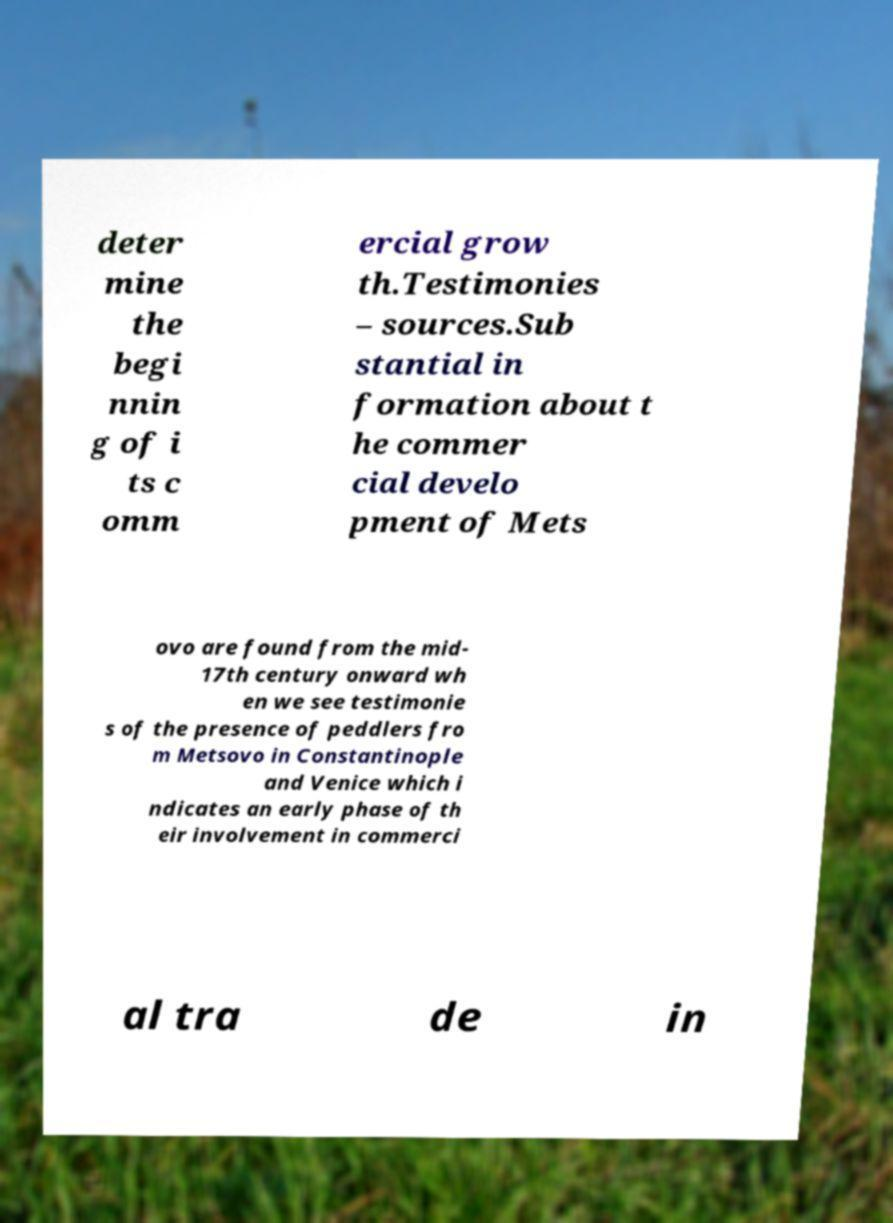What messages or text are displayed in this image? I need them in a readable, typed format. deter mine the begi nnin g of i ts c omm ercial grow th.Testimonies – sources.Sub stantial in formation about t he commer cial develo pment of Mets ovo are found from the mid- 17th century onward wh en we see testimonie s of the presence of peddlers fro m Metsovo in Constantinople and Venice which i ndicates an early phase of th eir involvement in commerci al tra de in 